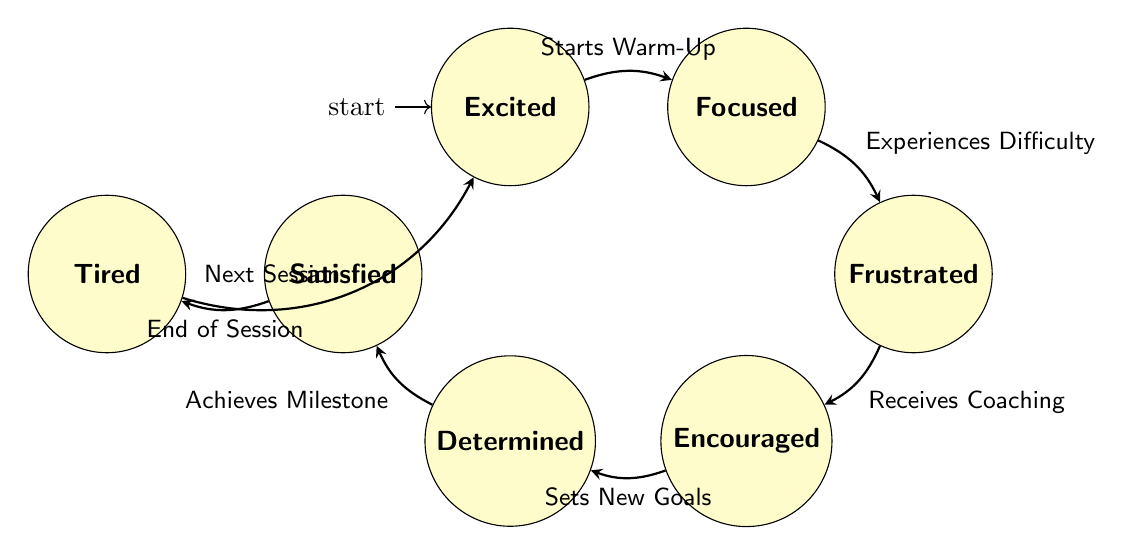What is the initial state of the gymnast? The initial state is indicated by the "initial" label on the excited node, which shows this is where the process starts.
Answer: Excited How many states are there in the diagram? By counting the distinct state nodes in the diagram, we find there are a total of seven states related to the emotional states of the gymnast during training.
Answer: Seven What transition occurs after the gymnast feels excited? The transition from the excited state happens when the gymnast starts the warm-up, leading to the focused state.
Answer: Starts Warm-Up Which state follows the focused state? The path from the focused state connects to the frustrated state when the gymnast experiences difficulty, indicating the next emotional state in the flow.
Answer: Frustrated What triggers the transition from the frustrated state to the encouraged state? The diagram shows that the transition is triggered by the gymnast receiving coaching, which provides the necessary support to move to the encouraged state.
Answer: Receives Coaching What is the last state before returning to excited? The tired state is the last state before the cycle loops back to the excited state, indicating the end of a training session followed by anticipation for the next one.
Answer: Tired If the gymnast achieves a milestone, which state do they enter next? Achieving a milestone leads the gymnast from the determined state to the satisfied state, indicating positive progress in their training journey.
Answer: Satisfied 